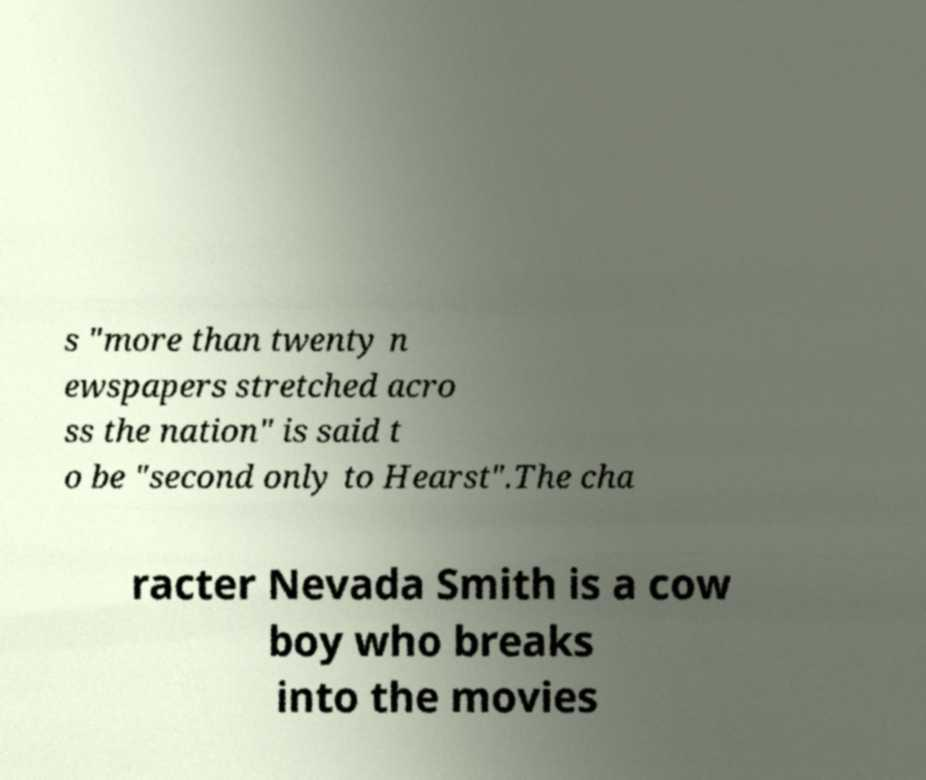Please read and relay the text visible in this image. What does it say? s "more than twenty n ewspapers stretched acro ss the nation" is said t o be "second only to Hearst".The cha racter Nevada Smith is a cow boy who breaks into the movies 